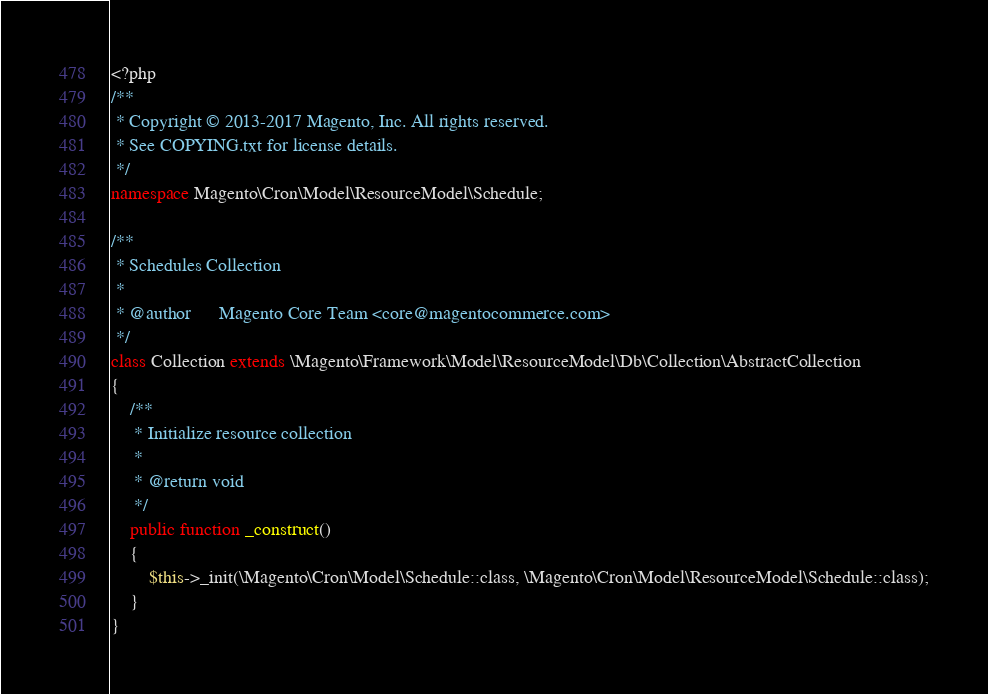Convert code to text. <code><loc_0><loc_0><loc_500><loc_500><_PHP_><?php
/**
 * Copyright © 2013-2017 Magento, Inc. All rights reserved.
 * See COPYING.txt for license details.
 */
namespace Magento\Cron\Model\ResourceModel\Schedule;

/**
 * Schedules Collection
 *
 * @author      Magento Core Team <core@magentocommerce.com>
 */
class Collection extends \Magento\Framework\Model\ResourceModel\Db\Collection\AbstractCollection
{
    /**
     * Initialize resource collection
     *
     * @return void
     */
    public function _construct()
    {
        $this->_init(\Magento\Cron\Model\Schedule::class, \Magento\Cron\Model\ResourceModel\Schedule::class);
    }
}
</code> 